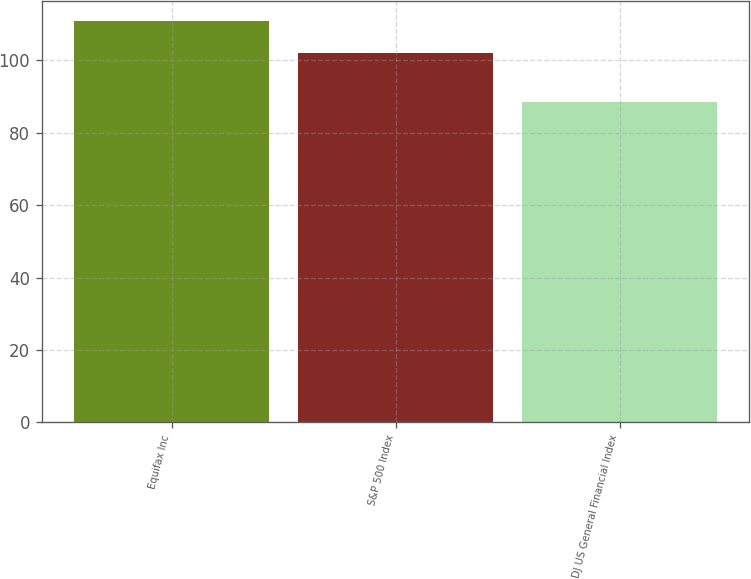<chart> <loc_0><loc_0><loc_500><loc_500><bar_chart><fcel>Equifax Inc<fcel>S&P 500 Index<fcel>DJ US General Financial Index<nl><fcel>110.87<fcel>102.11<fcel>88.38<nl></chart> 